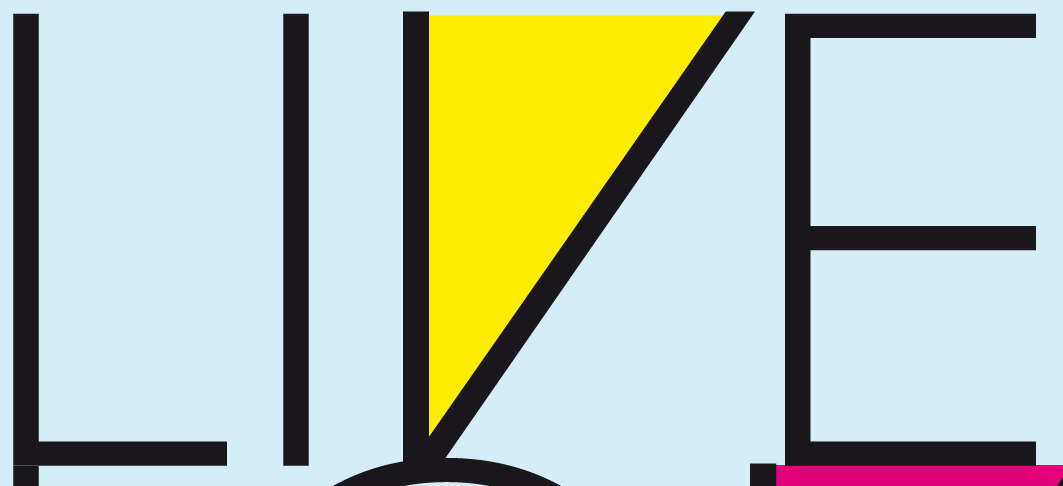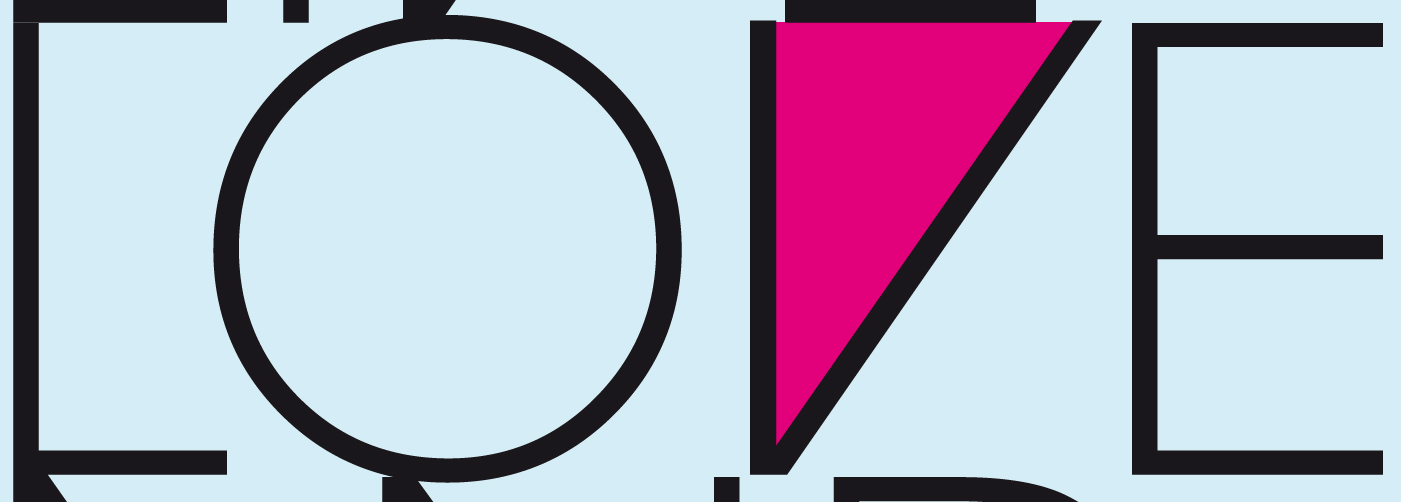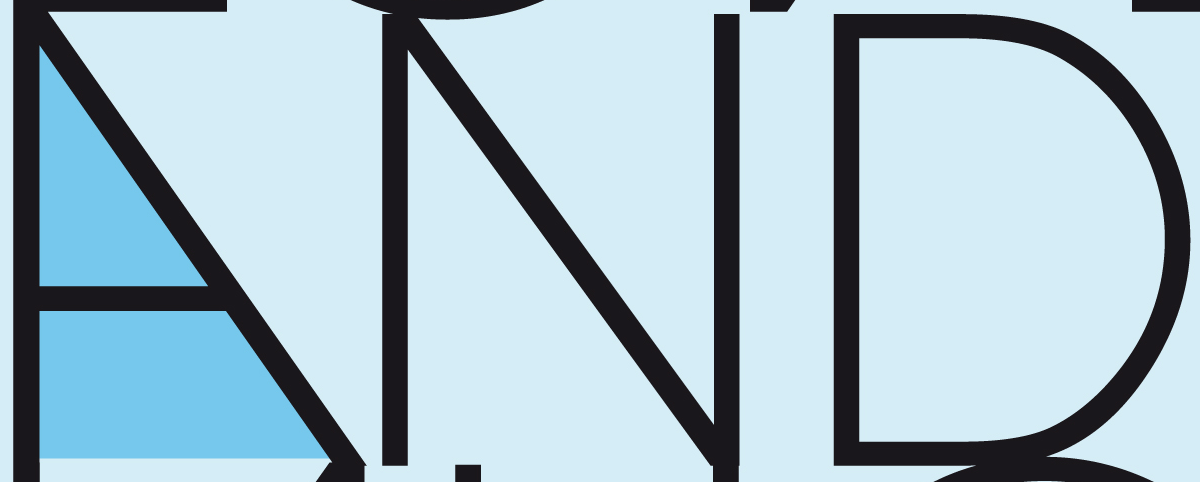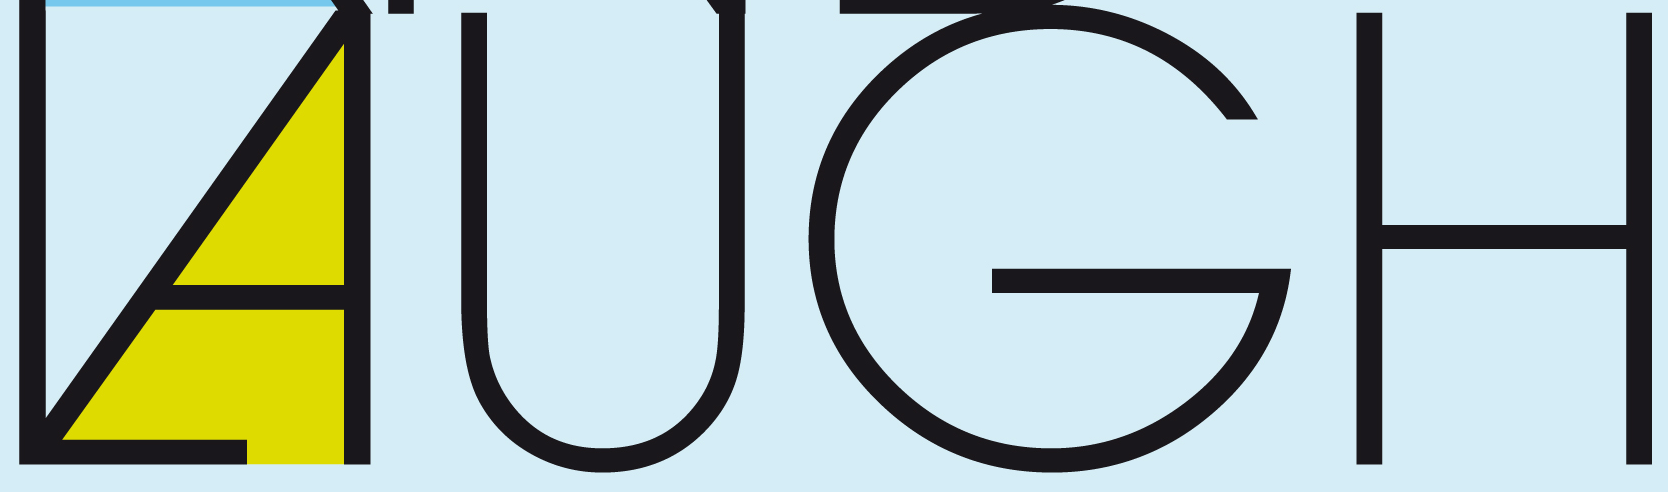What text appears in these images from left to right, separated by a semicolon? LIVE; LOVE; AND; LAUGH 